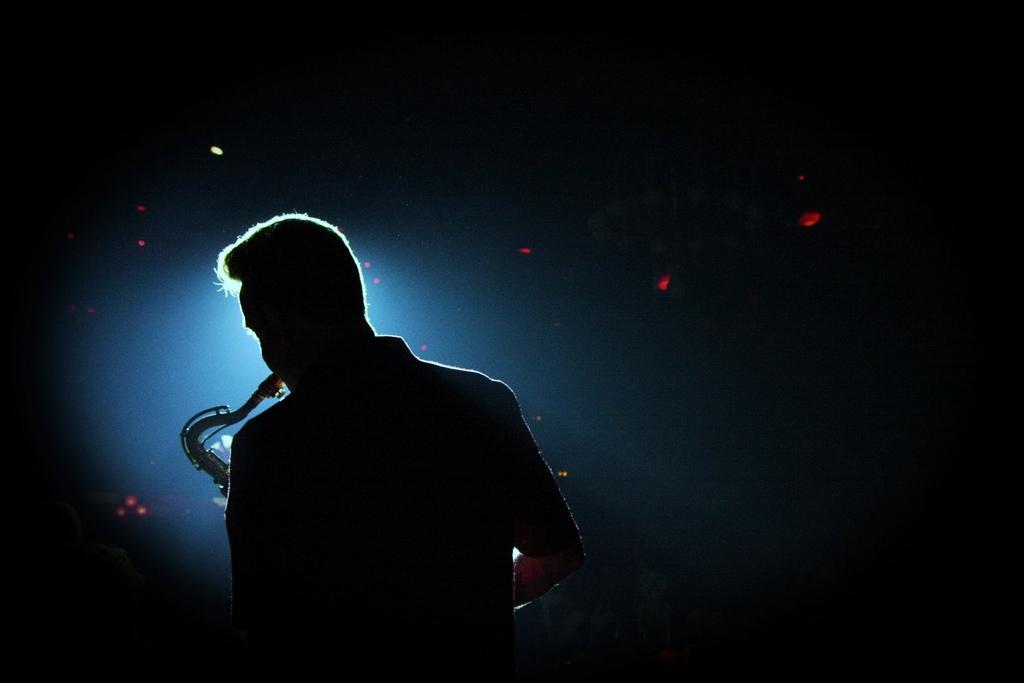How would you summarize this image in a sentence or two? In this image I can see a person is playing musical instrument. Background is in black,red and blue color. 